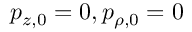<formula> <loc_0><loc_0><loc_500><loc_500>p _ { z , 0 } = 0 , p _ { \rho , 0 } = 0</formula> 